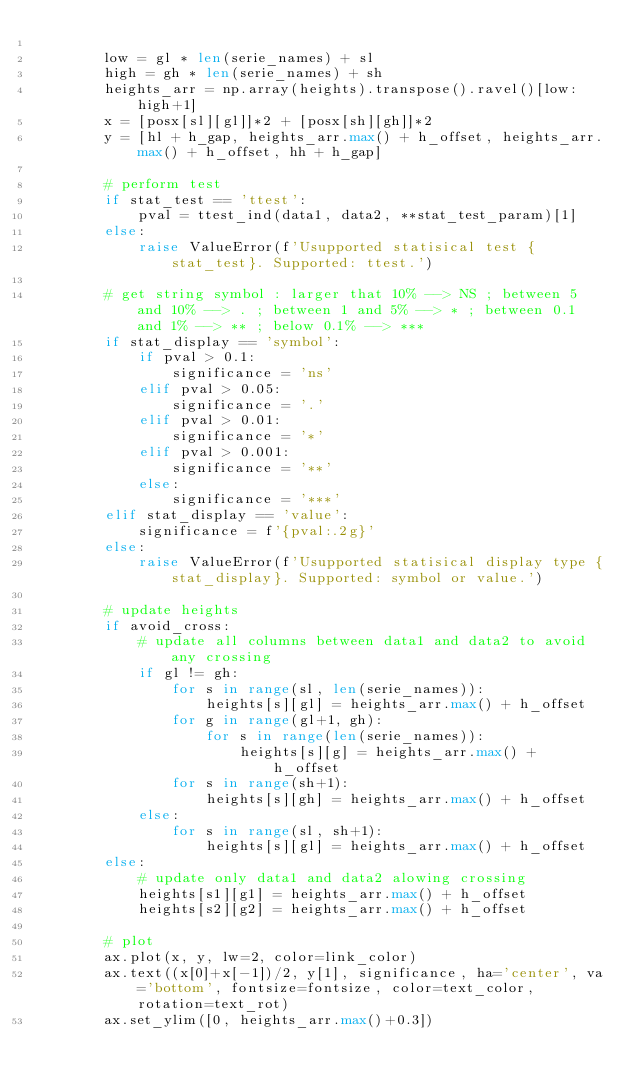Convert code to text. <code><loc_0><loc_0><loc_500><loc_500><_Python_>
        low = gl * len(serie_names) + sl
        high = gh * len(serie_names) + sh
        heights_arr = np.array(heights).transpose().ravel()[low:high+1]
        x = [posx[sl][gl]]*2 + [posx[sh][gh]]*2
        y = [hl + h_gap, heights_arr.max() + h_offset, heights_arr.max() + h_offset, hh + h_gap]

        # perform test
        if stat_test == 'ttest':
            pval = ttest_ind(data1, data2, **stat_test_param)[1]
        else:
            raise ValueError(f'Usupported statisical test {stat_test}. Supported: ttest.')

        # get string symbol : larger that 10% --> NS ; between 5 and 10% --> . ; between 1 and 5% --> * ; between 0.1 and 1% --> ** ; below 0.1% --> ***
        if stat_display == 'symbol':
            if pval > 0.1:
                significance = 'ns'
            elif pval > 0.05:
                significance = '.'
            elif pval > 0.01:
                significance = '*'
            elif pval > 0.001:
                significance = '**'
            else:
                significance = '***'
        elif stat_display == 'value':
            significance = f'{pval:.2g}'
        else:
            raise ValueError(f'Usupported statisical display type {stat_display}. Supported: symbol or value.')

        # update heights
        if avoid_cross:
            # update all columns between data1 and data2 to avoid any crossing
            if gl != gh:
                for s in range(sl, len(serie_names)):
                    heights[s][gl] = heights_arr.max() + h_offset
                for g in range(gl+1, gh):
                    for s in range(len(serie_names)):
                        heights[s][g] = heights_arr.max() + h_offset
                for s in range(sh+1):
                    heights[s][gh] = heights_arr.max() + h_offset
            else:
                for s in range(sl, sh+1):
                    heights[s][gl] = heights_arr.max() + h_offset
        else:
            # update only data1 and data2 alowing crossing
            heights[s1][g1] = heights_arr.max() + h_offset
            heights[s2][g2] = heights_arr.max() + h_offset

        # plot
        ax.plot(x, y, lw=2, color=link_color)
        ax.text((x[0]+x[-1])/2, y[1], significance, ha='center', va='bottom', fontsize=fontsize, color=text_color, rotation=text_rot)
        ax.set_ylim([0, heights_arr.max()+0.3])
</code> 